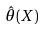<formula> <loc_0><loc_0><loc_500><loc_500>\hat { \theta } ( X )</formula> 